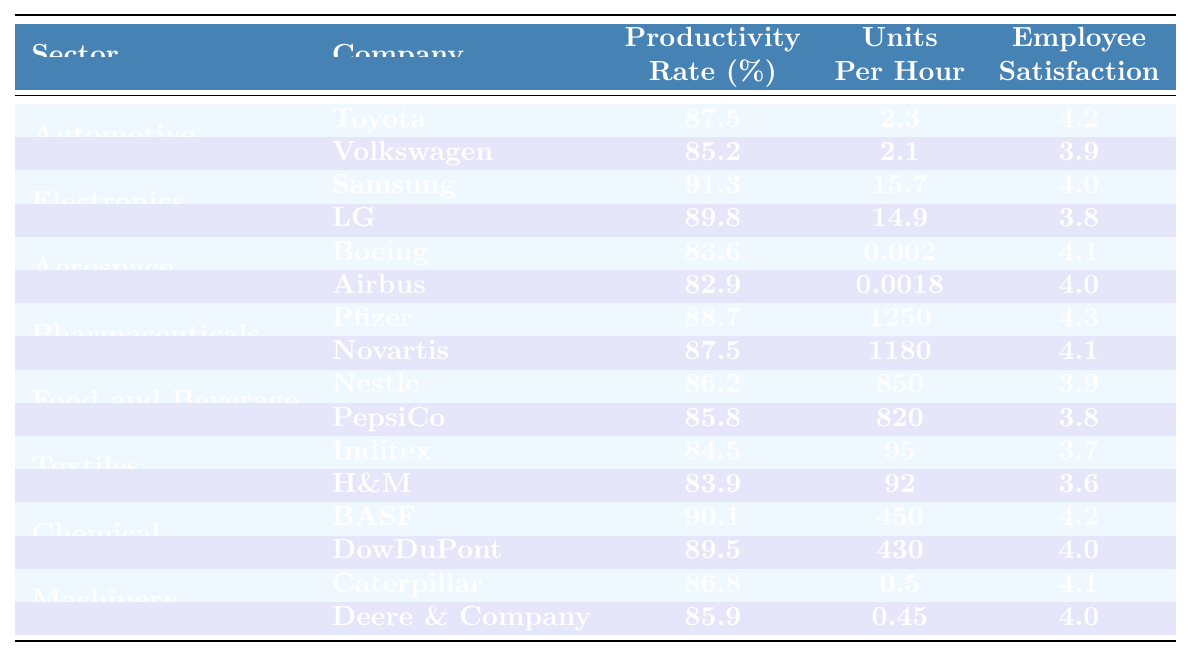What is the highest productivity rate among the sectors? Looking through the productivity rates of each company in the table, Samsung stands out with a productivity rate of 91.3%, which is higher than any other listed company.
Answer: 91.3% Which company in the Aerospace sector has the lowest productivity rate? The table shows that Airbus has a productivity rate of 82.9%, which is lower than Boeing's 83.6% in the same sector.
Answer: Airbus What is the average employee satisfaction in the Chemical sector? The employee satisfaction scores for BASF and DowDuPont are 4.2 and 4.0 respectively. The average is calculated as (4.2 + 4.0) / 2 = 4.1.
Answer: 4.1 How many sectors have an employee satisfaction rating of 4.0 or higher? Checking each sector's employee satisfaction values, we find that the sectors of Automotive, Electronics, Pharmaceuticals, and Chemical all have at least one company with a rating of 4.0 or better, leading to a total count of 5 companies across several sectors.
Answer: 5 Which sector has the highest average productivity rate? Calculating the averages: Automotive: (87.5 + 85.2) / 2 = 86.35; Electronics: (91.3 + 89.8) / 2 = 90.55; Aerospace: (83.6 + 82.9) / 2 = 83.25; Pharmaceuticals: (88.7 + 87.5) / 2 = 88.1; Food and Beverage: (86.2 + 85.8) / 2 = 86; Textiles: (84.5 + 83.9) / 2 = 84.2; Chemical: (90.1 + 89.5) / 2 = 89.8; Machinery: (86.8 + 85.9) / 2 = 85.85. Electronics has the highest average of 90.55%.
Answer: Electronics Is the productivity rate of Toyota higher than that of Pfizer? Comparing the two rates: Toyota has a productivity rate of 87.5% while Pfizer's productivity rate is 88.7%. Since 87.5% is less than 88.7%, Toyota's productivity rate is not higher.
Answer: No What is the combined productivity rate of companies in the Food and Beverage sector? The rates for Nestle and PepsiCo are 86.2% and 85.8% respectively, so we sum them, giving us 86.2 + 85.8 = 172.
Answer: 172 Which company has the highest units produced per hour in the Pharmaceuticals sector? In the Pharmaceuticals sector, records show that Pfizer has 1250 units per hour, which is greater than Novartis's 1180, making Pfizer the highest.
Answer: Pfizer What is the difference between the productivity rates of the highest and lowest in the Textiles sector? In the Textiles sector, Inditex has 84.5% and H&M has 83.9%. The difference is calculated as 84.5 - 83.9 = 0.6%.
Answer: 0.6% Does any company in the Aerospace sector exceed an employee satisfaction score of 4.0? Reviewing the scores, Boeing has a satisfaction score of 4.1, which is indeed higher than 4.0, while Airbus does not. Thus, one company does meet the criteria.
Answer: Yes What is the sector with the lowest average units produced per hour? The units produced per hour for the sectors are: Automotive (avg 2.2), Electronics (avg 15.3), Aerospace (avg 0.0019), Pharmaceuticals (avg 1215), Food and Beverage (avg 835), Textiles (avg 93.5), Chemical (avg 440), and Machinery (avg 0.475). Clearly, Aerospace has the lowest average units produced per hour.
Answer: Aerospace 